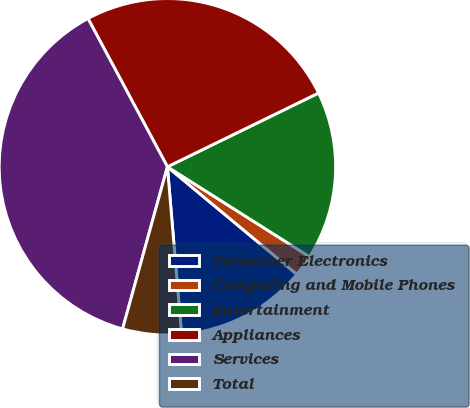Convert chart to OTSL. <chart><loc_0><loc_0><loc_500><loc_500><pie_chart><fcel>Consumer Electronics<fcel>Computing and Mobile Phones<fcel>Entertainment<fcel>Appliances<fcel>Services<fcel>Total<nl><fcel>12.63%<fcel>2.05%<fcel>16.21%<fcel>25.6%<fcel>37.88%<fcel>5.63%<nl></chart> 